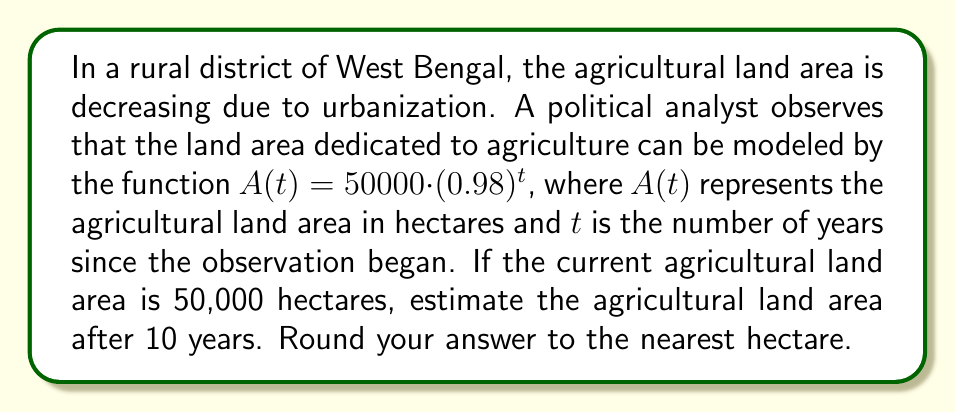Help me with this question. To solve this problem, we need to use the given exponential function and substitute the appropriate value for $t$. Let's break it down step-by-step:

1) The given function is $A(t) = 50000 \cdot (0.98)^t$

2) We need to find $A(10)$ since we're looking at the land area after 10 years

3) Let's substitute $t = 10$ into the function:

   $A(10) = 50000 \cdot (0.98)^{10}$

4) Now we need to calculate $(0.98)^{10}$:
   
   $(0.98)^{10} \approx 0.8171$ (rounded to 4 decimal places)

5) Multiply this by 50000:

   $50000 \cdot 0.8171 \approx 40855$

6) Rounding to the nearest hectare, we get 40,855 hectares.

This result shows that the agricultural land area will decrease from 50,000 hectares to approximately 40,855 hectares over a 10-year period, representing a significant reduction in available farmland.
Answer: 40,855 hectares 